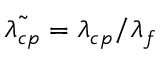<formula> <loc_0><loc_0><loc_500><loc_500>\tilde { \lambda _ { c p } } = \lambda _ { c p } / \lambda _ { f }</formula> 